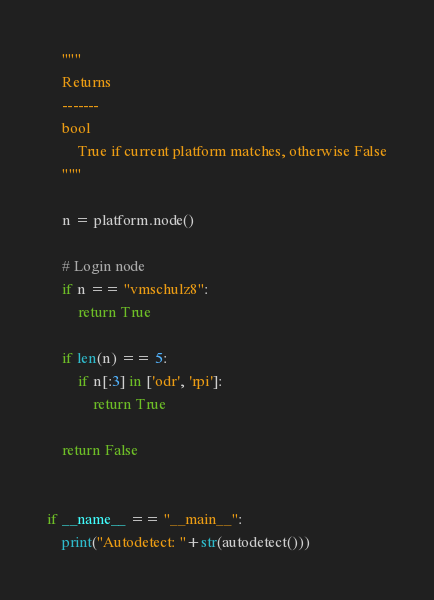Convert code to text. <code><loc_0><loc_0><loc_500><loc_500><_Python_>    """
    Returns
    -------
    bool
        True if current platform matches, otherwise False
    """

    n = platform.node()

    # Login node
    if n == "vmschulz8":
        return True

    if len(n) == 5:
        if n[:3] in ['odr', 'rpi']:
            return True

    return False


if __name__ == "__main__":
    print("Autodetect: "+str(autodetect()))

</code> 